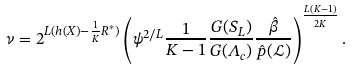<formula> <loc_0><loc_0><loc_500><loc_500>\nu = 2 ^ { L ( h ( X ) - \frac { 1 } { K } R ^ { * } ) } \left ( \psi ^ { 2 / L } \frac { 1 } { K - 1 } \frac { G ( S _ { L } ) } { G ( \Lambda _ { c } ) } \frac { \hat { \beta } } { \hat { p } ( \mathcal { L } ) } \right ) ^ { \frac { L ( K - 1 ) } { 2 K } } .</formula> 